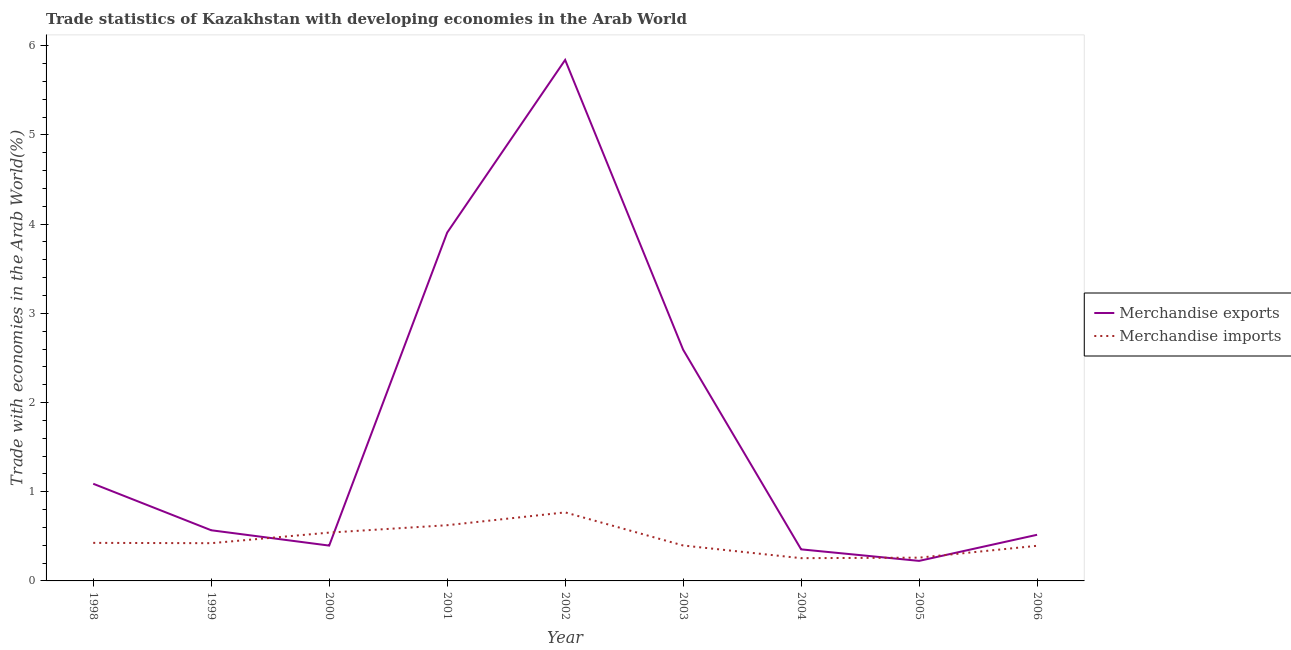How many different coloured lines are there?
Your response must be concise. 2. Is the number of lines equal to the number of legend labels?
Provide a succinct answer. Yes. What is the merchandise imports in 2000?
Offer a very short reply. 0.54. Across all years, what is the maximum merchandise imports?
Provide a succinct answer. 0.77. Across all years, what is the minimum merchandise imports?
Your answer should be compact. 0.26. In which year was the merchandise exports maximum?
Provide a short and direct response. 2002. In which year was the merchandise exports minimum?
Offer a very short reply. 2005. What is the total merchandise exports in the graph?
Offer a very short reply. 15.49. What is the difference between the merchandise exports in 2000 and that in 2005?
Ensure brevity in your answer.  0.17. What is the difference between the merchandise imports in 2004 and the merchandise exports in 2001?
Your answer should be compact. -3.65. What is the average merchandise imports per year?
Offer a terse response. 0.45. In the year 1999, what is the difference between the merchandise imports and merchandise exports?
Provide a short and direct response. -0.14. What is the ratio of the merchandise imports in 1999 to that in 2004?
Make the answer very short. 1.66. Is the difference between the merchandise exports in 2004 and 2005 greater than the difference between the merchandise imports in 2004 and 2005?
Provide a short and direct response. Yes. What is the difference between the highest and the second highest merchandise exports?
Provide a short and direct response. 1.94. What is the difference between the highest and the lowest merchandise imports?
Give a very brief answer. 0.51. Is the sum of the merchandise exports in 2001 and 2006 greater than the maximum merchandise imports across all years?
Offer a very short reply. Yes. Does the merchandise exports monotonically increase over the years?
Offer a terse response. No. Is the merchandise imports strictly greater than the merchandise exports over the years?
Offer a very short reply. No. Is the merchandise exports strictly less than the merchandise imports over the years?
Your response must be concise. No. How many lines are there?
Give a very brief answer. 2. What is the difference between two consecutive major ticks on the Y-axis?
Offer a terse response. 1. Are the values on the major ticks of Y-axis written in scientific E-notation?
Provide a succinct answer. No. Does the graph contain any zero values?
Your response must be concise. No. What is the title of the graph?
Your answer should be compact. Trade statistics of Kazakhstan with developing economies in the Arab World. What is the label or title of the X-axis?
Give a very brief answer. Year. What is the label or title of the Y-axis?
Offer a very short reply. Trade with economies in the Arab World(%). What is the Trade with economies in the Arab World(%) of Merchandise exports in 1998?
Provide a short and direct response. 1.09. What is the Trade with economies in the Arab World(%) of Merchandise imports in 1998?
Provide a short and direct response. 0.43. What is the Trade with economies in the Arab World(%) of Merchandise exports in 1999?
Ensure brevity in your answer.  0.57. What is the Trade with economies in the Arab World(%) of Merchandise imports in 1999?
Ensure brevity in your answer.  0.42. What is the Trade with economies in the Arab World(%) in Merchandise exports in 2000?
Offer a very short reply. 0.4. What is the Trade with economies in the Arab World(%) in Merchandise imports in 2000?
Offer a very short reply. 0.54. What is the Trade with economies in the Arab World(%) in Merchandise exports in 2001?
Ensure brevity in your answer.  3.91. What is the Trade with economies in the Arab World(%) of Merchandise imports in 2001?
Provide a short and direct response. 0.62. What is the Trade with economies in the Arab World(%) in Merchandise exports in 2002?
Provide a short and direct response. 5.84. What is the Trade with economies in the Arab World(%) in Merchandise imports in 2002?
Offer a terse response. 0.77. What is the Trade with economies in the Arab World(%) of Merchandise exports in 2003?
Your response must be concise. 2.59. What is the Trade with economies in the Arab World(%) in Merchandise imports in 2003?
Your response must be concise. 0.4. What is the Trade with economies in the Arab World(%) in Merchandise exports in 2004?
Give a very brief answer. 0.35. What is the Trade with economies in the Arab World(%) of Merchandise imports in 2004?
Keep it short and to the point. 0.26. What is the Trade with economies in the Arab World(%) in Merchandise exports in 2005?
Provide a short and direct response. 0.22. What is the Trade with economies in the Arab World(%) in Merchandise imports in 2005?
Your answer should be compact. 0.26. What is the Trade with economies in the Arab World(%) of Merchandise exports in 2006?
Give a very brief answer. 0.52. What is the Trade with economies in the Arab World(%) in Merchandise imports in 2006?
Your response must be concise. 0.39. Across all years, what is the maximum Trade with economies in the Arab World(%) of Merchandise exports?
Keep it short and to the point. 5.84. Across all years, what is the maximum Trade with economies in the Arab World(%) in Merchandise imports?
Your answer should be compact. 0.77. Across all years, what is the minimum Trade with economies in the Arab World(%) in Merchandise exports?
Offer a very short reply. 0.22. Across all years, what is the minimum Trade with economies in the Arab World(%) of Merchandise imports?
Offer a terse response. 0.26. What is the total Trade with economies in the Arab World(%) of Merchandise exports in the graph?
Give a very brief answer. 15.49. What is the total Trade with economies in the Arab World(%) of Merchandise imports in the graph?
Give a very brief answer. 4.09. What is the difference between the Trade with economies in the Arab World(%) of Merchandise exports in 1998 and that in 1999?
Ensure brevity in your answer.  0.52. What is the difference between the Trade with economies in the Arab World(%) in Merchandise imports in 1998 and that in 1999?
Make the answer very short. 0. What is the difference between the Trade with economies in the Arab World(%) in Merchandise exports in 1998 and that in 2000?
Offer a very short reply. 0.69. What is the difference between the Trade with economies in the Arab World(%) of Merchandise imports in 1998 and that in 2000?
Offer a very short reply. -0.12. What is the difference between the Trade with economies in the Arab World(%) of Merchandise exports in 1998 and that in 2001?
Provide a succinct answer. -2.82. What is the difference between the Trade with economies in the Arab World(%) in Merchandise imports in 1998 and that in 2001?
Your response must be concise. -0.2. What is the difference between the Trade with economies in the Arab World(%) in Merchandise exports in 1998 and that in 2002?
Your answer should be very brief. -4.75. What is the difference between the Trade with economies in the Arab World(%) of Merchandise imports in 1998 and that in 2002?
Your answer should be very brief. -0.34. What is the difference between the Trade with economies in the Arab World(%) in Merchandise exports in 1998 and that in 2003?
Your answer should be very brief. -1.5. What is the difference between the Trade with economies in the Arab World(%) in Merchandise imports in 1998 and that in 2003?
Your answer should be compact. 0.03. What is the difference between the Trade with economies in the Arab World(%) of Merchandise exports in 1998 and that in 2004?
Your answer should be very brief. 0.74. What is the difference between the Trade with economies in the Arab World(%) of Merchandise imports in 1998 and that in 2004?
Provide a short and direct response. 0.17. What is the difference between the Trade with economies in the Arab World(%) in Merchandise exports in 1998 and that in 2005?
Offer a very short reply. 0.86. What is the difference between the Trade with economies in the Arab World(%) of Merchandise imports in 1998 and that in 2005?
Provide a short and direct response. 0.17. What is the difference between the Trade with economies in the Arab World(%) in Merchandise exports in 1998 and that in 2006?
Your response must be concise. 0.57. What is the difference between the Trade with economies in the Arab World(%) of Merchandise imports in 1998 and that in 2006?
Provide a short and direct response. 0.03. What is the difference between the Trade with economies in the Arab World(%) in Merchandise exports in 1999 and that in 2000?
Make the answer very short. 0.17. What is the difference between the Trade with economies in the Arab World(%) in Merchandise imports in 1999 and that in 2000?
Provide a succinct answer. -0.12. What is the difference between the Trade with economies in the Arab World(%) of Merchandise exports in 1999 and that in 2001?
Offer a terse response. -3.34. What is the difference between the Trade with economies in the Arab World(%) of Merchandise imports in 1999 and that in 2001?
Your answer should be compact. -0.2. What is the difference between the Trade with economies in the Arab World(%) in Merchandise exports in 1999 and that in 2002?
Make the answer very short. -5.27. What is the difference between the Trade with economies in the Arab World(%) of Merchandise imports in 1999 and that in 2002?
Your answer should be compact. -0.35. What is the difference between the Trade with economies in the Arab World(%) of Merchandise exports in 1999 and that in 2003?
Make the answer very short. -2.02. What is the difference between the Trade with economies in the Arab World(%) in Merchandise imports in 1999 and that in 2003?
Make the answer very short. 0.03. What is the difference between the Trade with economies in the Arab World(%) in Merchandise exports in 1999 and that in 2004?
Keep it short and to the point. 0.21. What is the difference between the Trade with economies in the Arab World(%) of Merchandise imports in 1999 and that in 2004?
Provide a short and direct response. 0.17. What is the difference between the Trade with economies in the Arab World(%) of Merchandise exports in 1999 and that in 2005?
Keep it short and to the point. 0.34. What is the difference between the Trade with economies in the Arab World(%) in Merchandise imports in 1999 and that in 2005?
Give a very brief answer. 0.16. What is the difference between the Trade with economies in the Arab World(%) of Merchandise exports in 1999 and that in 2006?
Give a very brief answer. 0.05. What is the difference between the Trade with economies in the Arab World(%) of Merchandise imports in 1999 and that in 2006?
Ensure brevity in your answer.  0.03. What is the difference between the Trade with economies in the Arab World(%) of Merchandise exports in 2000 and that in 2001?
Give a very brief answer. -3.51. What is the difference between the Trade with economies in the Arab World(%) in Merchandise imports in 2000 and that in 2001?
Provide a succinct answer. -0.08. What is the difference between the Trade with economies in the Arab World(%) in Merchandise exports in 2000 and that in 2002?
Keep it short and to the point. -5.44. What is the difference between the Trade with economies in the Arab World(%) in Merchandise imports in 2000 and that in 2002?
Ensure brevity in your answer.  -0.23. What is the difference between the Trade with economies in the Arab World(%) in Merchandise exports in 2000 and that in 2003?
Make the answer very short. -2.2. What is the difference between the Trade with economies in the Arab World(%) in Merchandise imports in 2000 and that in 2003?
Keep it short and to the point. 0.14. What is the difference between the Trade with economies in the Arab World(%) in Merchandise exports in 2000 and that in 2004?
Offer a very short reply. 0.04. What is the difference between the Trade with economies in the Arab World(%) in Merchandise imports in 2000 and that in 2004?
Provide a succinct answer. 0.29. What is the difference between the Trade with economies in the Arab World(%) of Merchandise exports in 2000 and that in 2005?
Offer a very short reply. 0.17. What is the difference between the Trade with economies in the Arab World(%) of Merchandise imports in 2000 and that in 2005?
Provide a succinct answer. 0.28. What is the difference between the Trade with economies in the Arab World(%) in Merchandise exports in 2000 and that in 2006?
Provide a short and direct response. -0.12. What is the difference between the Trade with economies in the Arab World(%) in Merchandise imports in 2000 and that in 2006?
Your answer should be very brief. 0.15. What is the difference between the Trade with economies in the Arab World(%) in Merchandise exports in 2001 and that in 2002?
Offer a very short reply. -1.94. What is the difference between the Trade with economies in the Arab World(%) in Merchandise imports in 2001 and that in 2002?
Make the answer very short. -0.14. What is the difference between the Trade with economies in the Arab World(%) in Merchandise exports in 2001 and that in 2003?
Provide a succinct answer. 1.31. What is the difference between the Trade with economies in the Arab World(%) of Merchandise imports in 2001 and that in 2003?
Your answer should be very brief. 0.23. What is the difference between the Trade with economies in the Arab World(%) of Merchandise exports in 2001 and that in 2004?
Provide a succinct answer. 3.55. What is the difference between the Trade with economies in the Arab World(%) of Merchandise imports in 2001 and that in 2004?
Ensure brevity in your answer.  0.37. What is the difference between the Trade with economies in the Arab World(%) in Merchandise exports in 2001 and that in 2005?
Your response must be concise. 3.68. What is the difference between the Trade with economies in the Arab World(%) in Merchandise imports in 2001 and that in 2005?
Provide a short and direct response. 0.36. What is the difference between the Trade with economies in the Arab World(%) of Merchandise exports in 2001 and that in 2006?
Offer a very short reply. 3.39. What is the difference between the Trade with economies in the Arab World(%) of Merchandise imports in 2001 and that in 2006?
Ensure brevity in your answer.  0.23. What is the difference between the Trade with economies in the Arab World(%) in Merchandise exports in 2002 and that in 2003?
Your response must be concise. 3.25. What is the difference between the Trade with economies in the Arab World(%) of Merchandise imports in 2002 and that in 2003?
Keep it short and to the point. 0.37. What is the difference between the Trade with economies in the Arab World(%) of Merchandise exports in 2002 and that in 2004?
Offer a terse response. 5.49. What is the difference between the Trade with economies in the Arab World(%) of Merchandise imports in 2002 and that in 2004?
Your response must be concise. 0.51. What is the difference between the Trade with economies in the Arab World(%) in Merchandise exports in 2002 and that in 2005?
Give a very brief answer. 5.62. What is the difference between the Trade with economies in the Arab World(%) in Merchandise imports in 2002 and that in 2005?
Give a very brief answer. 0.51. What is the difference between the Trade with economies in the Arab World(%) of Merchandise exports in 2002 and that in 2006?
Provide a succinct answer. 5.32. What is the difference between the Trade with economies in the Arab World(%) in Merchandise imports in 2002 and that in 2006?
Your answer should be very brief. 0.37. What is the difference between the Trade with economies in the Arab World(%) of Merchandise exports in 2003 and that in 2004?
Offer a very short reply. 2.24. What is the difference between the Trade with economies in the Arab World(%) in Merchandise imports in 2003 and that in 2004?
Give a very brief answer. 0.14. What is the difference between the Trade with economies in the Arab World(%) in Merchandise exports in 2003 and that in 2005?
Give a very brief answer. 2.37. What is the difference between the Trade with economies in the Arab World(%) in Merchandise imports in 2003 and that in 2005?
Give a very brief answer. 0.14. What is the difference between the Trade with economies in the Arab World(%) of Merchandise exports in 2003 and that in 2006?
Your response must be concise. 2.07. What is the difference between the Trade with economies in the Arab World(%) in Merchandise imports in 2003 and that in 2006?
Your response must be concise. 0. What is the difference between the Trade with economies in the Arab World(%) in Merchandise exports in 2004 and that in 2005?
Ensure brevity in your answer.  0.13. What is the difference between the Trade with economies in the Arab World(%) of Merchandise imports in 2004 and that in 2005?
Give a very brief answer. -0.01. What is the difference between the Trade with economies in the Arab World(%) of Merchandise exports in 2004 and that in 2006?
Keep it short and to the point. -0.16. What is the difference between the Trade with economies in the Arab World(%) of Merchandise imports in 2004 and that in 2006?
Give a very brief answer. -0.14. What is the difference between the Trade with economies in the Arab World(%) of Merchandise exports in 2005 and that in 2006?
Your response must be concise. -0.29. What is the difference between the Trade with economies in the Arab World(%) of Merchandise imports in 2005 and that in 2006?
Provide a succinct answer. -0.13. What is the difference between the Trade with economies in the Arab World(%) in Merchandise exports in 1998 and the Trade with economies in the Arab World(%) in Merchandise imports in 1999?
Your response must be concise. 0.67. What is the difference between the Trade with economies in the Arab World(%) in Merchandise exports in 1998 and the Trade with economies in the Arab World(%) in Merchandise imports in 2000?
Provide a succinct answer. 0.55. What is the difference between the Trade with economies in the Arab World(%) of Merchandise exports in 1998 and the Trade with economies in the Arab World(%) of Merchandise imports in 2001?
Provide a short and direct response. 0.46. What is the difference between the Trade with economies in the Arab World(%) of Merchandise exports in 1998 and the Trade with economies in the Arab World(%) of Merchandise imports in 2002?
Ensure brevity in your answer.  0.32. What is the difference between the Trade with economies in the Arab World(%) of Merchandise exports in 1998 and the Trade with economies in the Arab World(%) of Merchandise imports in 2003?
Make the answer very short. 0.69. What is the difference between the Trade with economies in the Arab World(%) of Merchandise exports in 1998 and the Trade with economies in the Arab World(%) of Merchandise imports in 2004?
Make the answer very short. 0.83. What is the difference between the Trade with economies in the Arab World(%) in Merchandise exports in 1998 and the Trade with economies in the Arab World(%) in Merchandise imports in 2005?
Your answer should be compact. 0.83. What is the difference between the Trade with economies in the Arab World(%) in Merchandise exports in 1998 and the Trade with economies in the Arab World(%) in Merchandise imports in 2006?
Keep it short and to the point. 0.7. What is the difference between the Trade with economies in the Arab World(%) in Merchandise exports in 1999 and the Trade with economies in the Arab World(%) in Merchandise imports in 2000?
Ensure brevity in your answer.  0.03. What is the difference between the Trade with economies in the Arab World(%) of Merchandise exports in 1999 and the Trade with economies in the Arab World(%) of Merchandise imports in 2001?
Offer a terse response. -0.06. What is the difference between the Trade with economies in the Arab World(%) of Merchandise exports in 1999 and the Trade with economies in the Arab World(%) of Merchandise imports in 2002?
Your answer should be very brief. -0.2. What is the difference between the Trade with economies in the Arab World(%) of Merchandise exports in 1999 and the Trade with economies in the Arab World(%) of Merchandise imports in 2003?
Keep it short and to the point. 0.17. What is the difference between the Trade with economies in the Arab World(%) of Merchandise exports in 1999 and the Trade with economies in the Arab World(%) of Merchandise imports in 2004?
Provide a succinct answer. 0.31. What is the difference between the Trade with economies in the Arab World(%) of Merchandise exports in 1999 and the Trade with economies in the Arab World(%) of Merchandise imports in 2005?
Your response must be concise. 0.31. What is the difference between the Trade with economies in the Arab World(%) of Merchandise exports in 1999 and the Trade with economies in the Arab World(%) of Merchandise imports in 2006?
Offer a very short reply. 0.17. What is the difference between the Trade with economies in the Arab World(%) in Merchandise exports in 2000 and the Trade with economies in the Arab World(%) in Merchandise imports in 2001?
Ensure brevity in your answer.  -0.23. What is the difference between the Trade with economies in the Arab World(%) in Merchandise exports in 2000 and the Trade with economies in the Arab World(%) in Merchandise imports in 2002?
Your answer should be compact. -0.37. What is the difference between the Trade with economies in the Arab World(%) of Merchandise exports in 2000 and the Trade with economies in the Arab World(%) of Merchandise imports in 2003?
Provide a succinct answer. -0. What is the difference between the Trade with economies in the Arab World(%) of Merchandise exports in 2000 and the Trade with economies in the Arab World(%) of Merchandise imports in 2004?
Ensure brevity in your answer.  0.14. What is the difference between the Trade with economies in the Arab World(%) in Merchandise exports in 2000 and the Trade with economies in the Arab World(%) in Merchandise imports in 2005?
Your answer should be compact. 0.14. What is the difference between the Trade with economies in the Arab World(%) in Merchandise exports in 2000 and the Trade with economies in the Arab World(%) in Merchandise imports in 2006?
Your answer should be very brief. 0. What is the difference between the Trade with economies in the Arab World(%) in Merchandise exports in 2001 and the Trade with economies in the Arab World(%) in Merchandise imports in 2002?
Offer a terse response. 3.14. What is the difference between the Trade with economies in the Arab World(%) of Merchandise exports in 2001 and the Trade with economies in the Arab World(%) of Merchandise imports in 2003?
Make the answer very short. 3.51. What is the difference between the Trade with economies in the Arab World(%) of Merchandise exports in 2001 and the Trade with economies in the Arab World(%) of Merchandise imports in 2004?
Provide a short and direct response. 3.65. What is the difference between the Trade with economies in the Arab World(%) in Merchandise exports in 2001 and the Trade with economies in the Arab World(%) in Merchandise imports in 2005?
Give a very brief answer. 3.64. What is the difference between the Trade with economies in the Arab World(%) in Merchandise exports in 2001 and the Trade with economies in the Arab World(%) in Merchandise imports in 2006?
Your response must be concise. 3.51. What is the difference between the Trade with economies in the Arab World(%) of Merchandise exports in 2002 and the Trade with economies in the Arab World(%) of Merchandise imports in 2003?
Your answer should be compact. 5.44. What is the difference between the Trade with economies in the Arab World(%) of Merchandise exports in 2002 and the Trade with economies in the Arab World(%) of Merchandise imports in 2004?
Your answer should be very brief. 5.59. What is the difference between the Trade with economies in the Arab World(%) in Merchandise exports in 2002 and the Trade with economies in the Arab World(%) in Merchandise imports in 2005?
Provide a short and direct response. 5.58. What is the difference between the Trade with economies in the Arab World(%) in Merchandise exports in 2002 and the Trade with economies in the Arab World(%) in Merchandise imports in 2006?
Your answer should be very brief. 5.45. What is the difference between the Trade with economies in the Arab World(%) of Merchandise exports in 2003 and the Trade with economies in the Arab World(%) of Merchandise imports in 2004?
Keep it short and to the point. 2.34. What is the difference between the Trade with economies in the Arab World(%) in Merchandise exports in 2003 and the Trade with economies in the Arab World(%) in Merchandise imports in 2005?
Ensure brevity in your answer.  2.33. What is the difference between the Trade with economies in the Arab World(%) in Merchandise exports in 2003 and the Trade with economies in the Arab World(%) in Merchandise imports in 2006?
Ensure brevity in your answer.  2.2. What is the difference between the Trade with economies in the Arab World(%) of Merchandise exports in 2004 and the Trade with economies in the Arab World(%) of Merchandise imports in 2005?
Give a very brief answer. 0.09. What is the difference between the Trade with economies in the Arab World(%) of Merchandise exports in 2004 and the Trade with economies in the Arab World(%) of Merchandise imports in 2006?
Your answer should be compact. -0.04. What is the difference between the Trade with economies in the Arab World(%) in Merchandise exports in 2005 and the Trade with economies in the Arab World(%) in Merchandise imports in 2006?
Give a very brief answer. -0.17. What is the average Trade with economies in the Arab World(%) of Merchandise exports per year?
Offer a very short reply. 1.72. What is the average Trade with economies in the Arab World(%) of Merchandise imports per year?
Provide a short and direct response. 0.45. In the year 1998, what is the difference between the Trade with economies in the Arab World(%) in Merchandise exports and Trade with economies in the Arab World(%) in Merchandise imports?
Your response must be concise. 0.66. In the year 1999, what is the difference between the Trade with economies in the Arab World(%) of Merchandise exports and Trade with economies in the Arab World(%) of Merchandise imports?
Provide a succinct answer. 0.14. In the year 2000, what is the difference between the Trade with economies in the Arab World(%) in Merchandise exports and Trade with economies in the Arab World(%) in Merchandise imports?
Your response must be concise. -0.15. In the year 2001, what is the difference between the Trade with economies in the Arab World(%) of Merchandise exports and Trade with economies in the Arab World(%) of Merchandise imports?
Offer a terse response. 3.28. In the year 2002, what is the difference between the Trade with economies in the Arab World(%) of Merchandise exports and Trade with economies in the Arab World(%) of Merchandise imports?
Keep it short and to the point. 5.07. In the year 2003, what is the difference between the Trade with economies in the Arab World(%) of Merchandise exports and Trade with economies in the Arab World(%) of Merchandise imports?
Offer a very short reply. 2.19. In the year 2004, what is the difference between the Trade with economies in the Arab World(%) in Merchandise exports and Trade with economies in the Arab World(%) in Merchandise imports?
Offer a terse response. 0.1. In the year 2005, what is the difference between the Trade with economies in the Arab World(%) in Merchandise exports and Trade with economies in the Arab World(%) in Merchandise imports?
Your answer should be very brief. -0.04. In the year 2006, what is the difference between the Trade with economies in the Arab World(%) of Merchandise exports and Trade with economies in the Arab World(%) of Merchandise imports?
Your answer should be compact. 0.12. What is the ratio of the Trade with economies in the Arab World(%) of Merchandise exports in 1998 to that in 1999?
Make the answer very short. 1.92. What is the ratio of the Trade with economies in the Arab World(%) of Merchandise exports in 1998 to that in 2000?
Keep it short and to the point. 2.75. What is the ratio of the Trade with economies in the Arab World(%) of Merchandise imports in 1998 to that in 2000?
Your response must be concise. 0.79. What is the ratio of the Trade with economies in the Arab World(%) of Merchandise exports in 1998 to that in 2001?
Keep it short and to the point. 0.28. What is the ratio of the Trade with economies in the Arab World(%) of Merchandise imports in 1998 to that in 2001?
Your answer should be very brief. 0.68. What is the ratio of the Trade with economies in the Arab World(%) of Merchandise exports in 1998 to that in 2002?
Keep it short and to the point. 0.19. What is the ratio of the Trade with economies in the Arab World(%) of Merchandise imports in 1998 to that in 2002?
Provide a short and direct response. 0.56. What is the ratio of the Trade with economies in the Arab World(%) in Merchandise exports in 1998 to that in 2003?
Your answer should be compact. 0.42. What is the ratio of the Trade with economies in the Arab World(%) in Merchandise imports in 1998 to that in 2003?
Ensure brevity in your answer.  1.07. What is the ratio of the Trade with economies in the Arab World(%) of Merchandise exports in 1998 to that in 2004?
Your answer should be compact. 3.08. What is the ratio of the Trade with economies in the Arab World(%) of Merchandise imports in 1998 to that in 2004?
Your answer should be very brief. 1.67. What is the ratio of the Trade with economies in the Arab World(%) of Merchandise exports in 1998 to that in 2005?
Make the answer very short. 4.85. What is the ratio of the Trade with economies in the Arab World(%) of Merchandise imports in 1998 to that in 2005?
Offer a very short reply. 1.64. What is the ratio of the Trade with economies in the Arab World(%) of Merchandise exports in 1998 to that in 2006?
Ensure brevity in your answer.  2.11. What is the ratio of the Trade with economies in the Arab World(%) of Merchandise imports in 1998 to that in 2006?
Your answer should be very brief. 1.08. What is the ratio of the Trade with economies in the Arab World(%) in Merchandise exports in 1999 to that in 2000?
Your answer should be compact. 1.43. What is the ratio of the Trade with economies in the Arab World(%) in Merchandise imports in 1999 to that in 2000?
Give a very brief answer. 0.78. What is the ratio of the Trade with economies in the Arab World(%) in Merchandise exports in 1999 to that in 2001?
Keep it short and to the point. 0.15. What is the ratio of the Trade with economies in the Arab World(%) of Merchandise imports in 1999 to that in 2001?
Provide a short and direct response. 0.68. What is the ratio of the Trade with economies in the Arab World(%) of Merchandise exports in 1999 to that in 2002?
Make the answer very short. 0.1. What is the ratio of the Trade with economies in the Arab World(%) in Merchandise imports in 1999 to that in 2002?
Offer a terse response. 0.55. What is the ratio of the Trade with economies in the Arab World(%) of Merchandise exports in 1999 to that in 2003?
Provide a succinct answer. 0.22. What is the ratio of the Trade with economies in the Arab World(%) of Merchandise imports in 1999 to that in 2003?
Your answer should be compact. 1.07. What is the ratio of the Trade with economies in the Arab World(%) in Merchandise exports in 1999 to that in 2004?
Ensure brevity in your answer.  1.61. What is the ratio of the Trade with economies in the Arab World(%) in Merchandise imports in 1999 to that in 2004?
Give a very brief answer. 1.66. What is the ratio of the Trade with economies in the Arab World(%) in Merchandise exports in 1999 to that in 2005?
Offer a terse response. 2.53. What is the ratio of the Trade with economies in the Arab World(%) in Merchandise imports in 1999 to that in 2005?
Provide a short and direct response. 1.62. What is the ratio of the Trade with economies in the Arab World(%) in Merchandise exports in 1999 to that in 2006?
Your answer should be very brief. 1.1. What is the ratio of the Trade with economies in the Arab World(%) of Merchandise imports in 1999 to that in 2006?
Your answer should be very brief. 1.07. What is the ratio of the Trade with economies in the Arab World(%) in Merchandise exports in 2000 to that in 2001?
Ensure brevity in your answer.  0.1. What is the ratio of the Trade with economies in the Arab World(%) of Merchandise imports in 2000 to that in 2001?
Offer a very short reply. 0.87. What is the ratio of the Trade with economies in the Arab World(%) of Merchandise exports in 2000 to that in 2002?
Your answer should be very brief. 0.07. What is the ratio of the Trade with economies in the Arab World(%) of Merchandise imports in 2000 to that in 2002?
Your response must be concise. 0.7. What is the ratio of the Trade with economies in the Arab World(%) in Merchandise exports in 2000 to that in 2003?
Provide a succinct answer. 0.15. What is the ratio of the Trade with economies in the Arab World(%) in Merchandise imports in 2000 to that in 2003?
Your answer should be very brief. 1.36. What is the ratio of the Trade with economies in the Arab World(%) in Merchandise exports in 2000 to that in 2004?
Ensure brevity in your answer.  1.12. What is the ratio of the Trade with economies in the Arab World(%) in Merchandise imports in 2000 to that in 2004?
Your answer should be very brief. 2.12. What is the ratio of the Trade with economies in the Arab World(%) of Merchandise exports in 2000 to that in 2005?
Provide a short and direct response. 1.76. What is the ratio of the Trade with economies in the Arab World(%) in Merchandise imports in 2000 to that in 2005?
Keep it short and to the point. 2.08. What is the ratio of the Trade with economies in the Arab World(%) in Merchandise exports in 2000 to that in 2006?
Make the answer very short. 0.77. What is the ratio of the Trade with economies in the Arab World(%) in Merchandise imports in 2000 to that in 2006?
Your answer should be compact. 1.38. What is the ratio of the Trade with economies in the Arab World(%) in Merchandise exports in 2001 to that in 2002?
Offer a terse response. 0.67. What is the ratio of the Trade with economies in the Arab World(%) in Merchandise imports in 2001 to that in 2002?
Your answer should be compact. 0.81. What is the ratio of the Trade with economies in the Arab World(%) in Merchandise exports in 2001 to that in 2003?
Your response must be concise. 1.51. What is the ratio of the Trade with economies in the Arab World(%) of Merchandise imports in 2001 to that in 2003?
Offer a very short reply. 1.57. What is the ratio of the Trade with economies in the Arab World(%) in Merchandise exports in 2001 to that in 2004?
Your answer should be compact. 11.03. What is the ratio of the Trade with economies in the Arab World(%) in Merchandise imports in 2001 to that in 2004?
Provide a succinct answer. 2.45. What is the ratio of the Trade with economies in the Arab World(%) of Merchandise exports in 2001 to that in 2005?
Keep it short and to the point. 17.38. What is the ratio of the Trade with economies in the Arab World(%) in Merchandise imports in 2001 to that in 2005?
Your answer should be very brief. 2.39. What is the ratio of the Trade with economies in the Arab World(%) of Merchandise exports in 2001 to that in 2006?
Offer a very short reply. 7.55. What is the ratio of the Trade with economies in the Arab World(%) of Merchandise imports in 2001 to that in 2006?
Offer a very short reply. 1.59. What is the ratio of the Trade with economies in the Arab World(%) in Merchandise exports in 2002 to that in 2003?
Offer a very short reply. 2.25. What is the ratio of the Trade with economies in the Arab World(%) in Merchandise imports in 2002 to that in 2003?
Your response must be concise. 1.93. What is the ratio of the Trade with economies in the Arab World(%) in Merchandise exports in 2002 to that in 2004?
Your answer should be very brief. 16.51. What is the ratio of the Trade with economies in the Arab World(%) in Merchandise imports in 2002 to that in 2004?
Provide a short and direct response. 3.01. What is the ratio of the Trade with economies in the Arab World(%) of Merchandise exports in 2002 to that in 2005?
Make the answer very short. 26. What is the ratio of the Trade with economies in the Arab World(%) of Merchandise imports in 2002 to that in 2005?
Provide a short and direct response. 2.95. What is the ratio of the Trade with economies in the Arab World(%) in Merchandise exports in 2002 to that in 2006?
Your response must be concise. 11.29. What is the ratio of the Trade with economies in the Arab World(%) in Merchandise imports in 2002 to that in 2006?
Offer a very short reply. 1.95. What is the ratio of the Trade with economies in the Arab World(%) in Merchandise exports in 2003 to that in 2004?
Your response must be concise. 7.32. What is the ratio of the Trade with economies in the Arab World(%) in Merchandise imports in 2003 to that in 2004?
Provide a short and direct response. 1.56. What is the ratio of the Trade with economies in the Arab World(%) of Merchandise exports in 2003 to that in 2005?
Your response must be concise. 11.54. What is the ratio of the Trade with economies in the Arab World(%) in Merchandise imports in 2003 to that in 2005?
Your answer should be very brief. 1.52. What is the ratio of the Trade with economies in the Arab World(%) in Merchandise exports in 2003 to that in 2006?
Provide a succinct answer. 5.01. What is the ratio of the Trade with economies in the Arab World(%) in Merchandise imports in 2003 to that in 2006?
Ensure brevity in your answer.  1.01. What is the ratio of the Trade with economies in the Arab World(%) of Merchandise exports in 2004 to that in 2005?
Offer a very short reply. 1.58. What is the ratio of the Trade with economies in the Arab World(%) of Merchandise imports in 2004 to that in 2005?
Ensure brevity in your answer.  0.98. What is the ratio of the Trade with economies in the Arab World(%) of Merchandise exports in 2004 to that in 2006?
Keep it short and to the point. 0.68. What is the ratio of the Trade with economies in the Arab World(%) in Merchandise imports in 2004 to that in 2006?
Keep it short and to the point. 0.65. What is the ratio of the Trade with economies in the Arab World(%) in Merchandise exports in 2005 to that in 2006?
Keep it short and to the point. 0.43. What is the ratio of the Trade with economies in the Arab World(%) of Merchandise imports in 2005 to that in 2006?
Your answer should be very brief. 0.66. What is the difference between the highest and the second highest Trade with economies in the Arab World(%) of Merchandise exports?
Give a very brief answer. 1.94. What is the difference between the highest and the second highest Trade with economies in the Arab World(%) of Merchandise imports?
Make the answer very short. 0.14. What is the difference between the highest and the lowest Trade with economies in the Arab World(%) in Merchandise exports?
Provide a succinct answer. 5.62. What is the difference between the highest and the lowest Trade with economies in the Arab World(%) in Merchandise imports?
Your response must be concise. 0.51. 